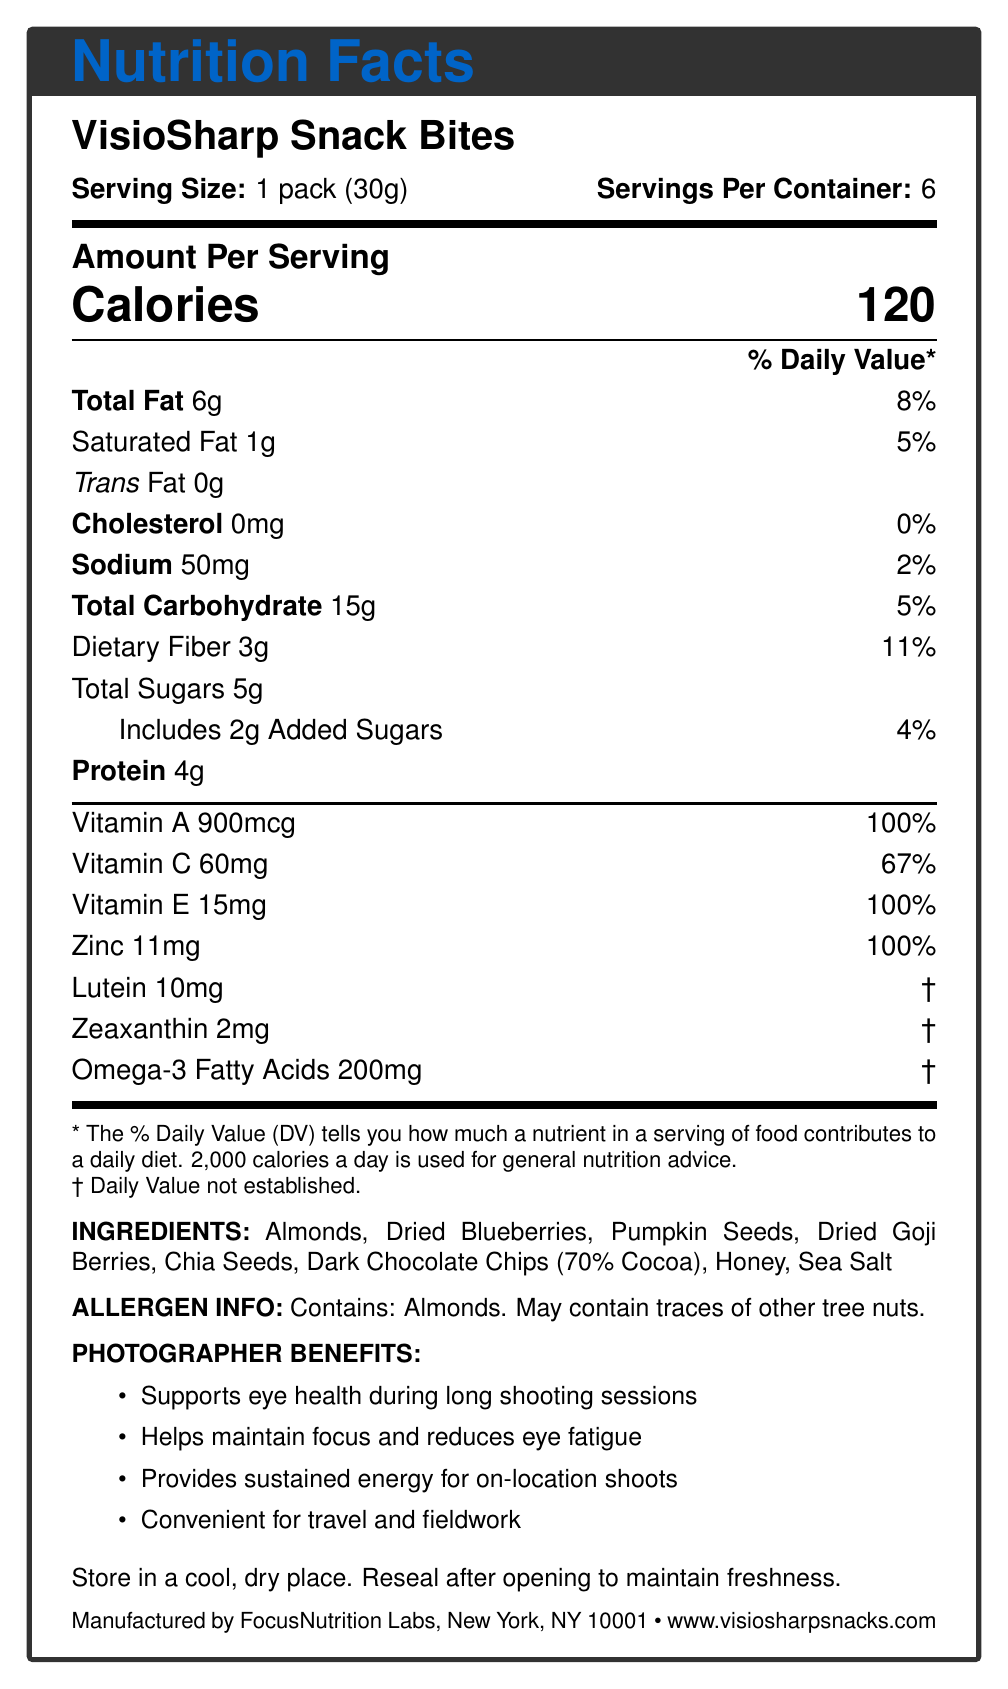what is the serving size of VisioSharp Snack Bites? The document states that the serving size is 1 pack, which weighs 30 grams.
Answer: 1 pack (30g) what percentage of the daily value of Vitamin E does one serving of VisioSharp Snack Bites provide? The document specifies that one serving provides 15mg of Vitamin E, which is 100% of the daily value.
Answer: 100% how many servings are there in a container of VisioSharp Snack Bites? The document mentions that there are 6 servings per container.
Answer: 6 what is the amount of Omega-3 Fatty Acids in a serving of VisioSharp Snack Bites? The document lists that each serving contains 200mg of Omega-3 Fatty Acids.
Answer: 200mg does the product contain any cholesterol? The document indicates that the product has 0mg of cholesterol, which is 0% of the daily value.
Answer: No which ingredient in VisioSharp Snack Bites is high in vitamin E? A. Dried Goji Berries B. Pumpkins Seeds C. Almonds D. Honey The document states that almonds are high in vitamin E, an antioxidant.
Answer: C. Almonds what is the main source of protein in VisioSharp Snack Bites? A. Almonds B. Honey C. Chia Seeds D. Dried Blueberries While multiple ingredients contain protein, almonds are specifically of high nutritional value regarding protein.
Answer: A. Almonds do VisioSharp Snack Bites contain trans fat? Yes/No The document specifies that the trans fat content is 0g.
Answer: No summarize the primary benefits of VisioSharp Snack Bites for photographers. These benefits are mentioned under the 'Photographer Benefits' section and directly relate to the needs of professional photographers.
Answer: VisioSharp Snack Bites support eye health, help maintain focus and reduce eye fatigue, provide sustained energy for on-location shoots, and are convenient for travel and fieldwork. how many grams of dietary fiber are in a serving of VisioSharp Snack Bites? The document states that each serving contains 3g of dietary fiber, which corresponds to 11% of the daily value.
Answer: 3g what company manufactures VisioSharp Snack Bites? The document lists FocusNutrition Labs as the manufacturer, located in New York, NY.
Answer: FocusNutrition Labs how much sodium is in one serving of VisioSharp Snack Bites? The document mentions that one serving contains 50mg of sodium, which is 2% of the daily value.
Answer: 50mg how many calories are in one serving of VisioSharp Snack Bites? The document indicates that one serving has 120 calories.
Answer: 120 what website can be visited for more information about VisioSharp Snack Bites? The document provides this URL for more product information.
Answer: www.visiosharpsnacks.com what are the allergens present in VisioSharp Snack Bites? The document's allergen information specifies almonds and possible traces of other tree nuts.
Answer: Contains: Almonds. May contain traces of other tree nuts. which nutrient in VisioSharp Snack Bites contributes 100% of its daily value and is measured at 900mcg? The document states that one serving provides 100% of the daily value for Vitamin A, measured at 900mcg.
Answer: Vitamin A what is the main idea of the document? The document gives insight into the nutritional composition, health benefits for photographers, and key ingredients of the snack bites.
Answer: The document provides nutritional information, benefits for photographers, and ingredient details for VisioSharp Snack Bites, an antioxidant-rich snack formulated to support eye health. what is the source of added sugars in VisioSharp Snack Bites? The document lists honey as an ingredient, which is the probable source of the 2g of added sugars.
Answer: Honey what are some key ingredients in VisioSharp Snack Bites related to eye health? The document mentions these ingredients and their specific benefits for eye health.
Answer: Almonds, Dried Blueberries, Goji Berries, Dark Chocolate how does the Vitamin C content in VisioSharp Snack Bites compare to the daily value? The document indicates that each serving contains 60mg of Vitamin C, which is 67% of the daily value.
Answer: 60mg provides 67% of the daily value. what is the function of Lutein in VisioSharp Snack Bites? The document lists the amount of Lutein but does not explain its function.
Answer: Not enough information 